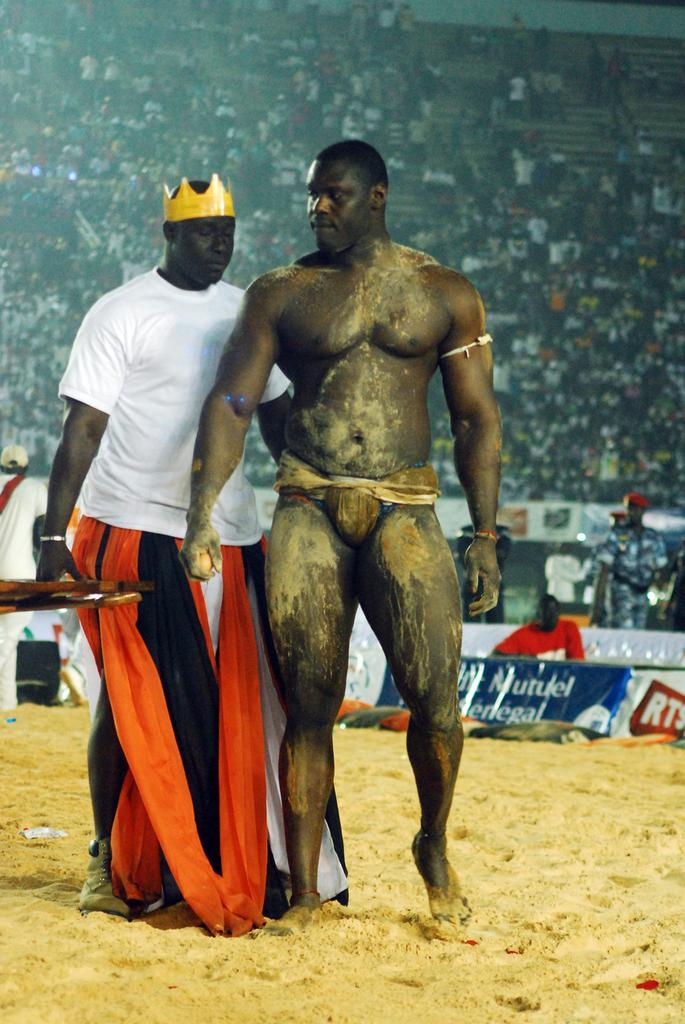Describe this image in one or two sentences. In this image I can see two persons are standing in the front. I can see the left one is wearing white colour t shirt and I can also see a yellow colour crown on his head. In the background I can see few boards and few people. 